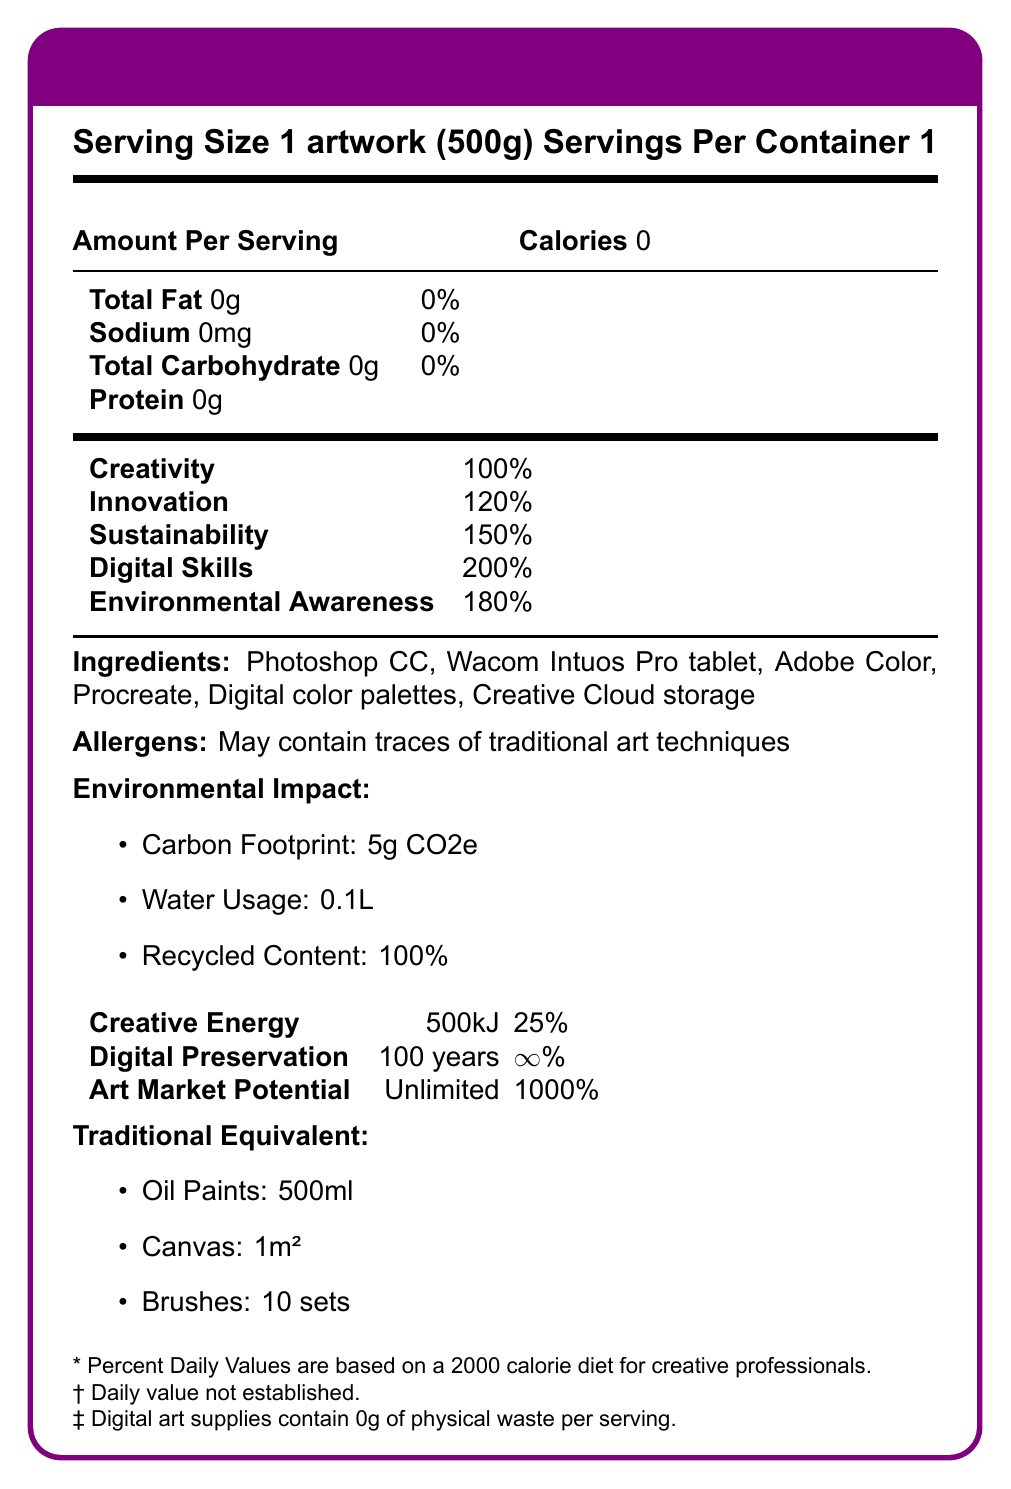What is the serving size of the artwork? The serving size is mentioned at the top of the label as "Serving Size 1 artwork (500g)".
Answer: 1 artwork (500g) How many calories are there per serving? The number of calories per serving is listed as 0 under "Amount Per Serving".
Answer: 0 What is the daily value percentage of Creativity? The daily value percentage of Creativity is given as 100%.
Answer: 100% Which ingredient might contain traces of traditional art techniques? Under "Allergens," it is mentioned that "May contain traces of traditional art techniques," referring to all the listed ingredients.
Answer: All of them What is the water usage for digital art supplies per serving? The "Environmental Impact" section lists the water usage as 0.1L.
Answer: 0.1L What is the carbon footprint of digital art supplies? A. 5g CO2e B. 100g CO2e C. 500g CO2e D. 10g CO2e The correct option is A, as stated under "Environmental Impact".
Answer: A. 5g CO2e Which of the following is not listed as an ingredient? A. Photoshop CC B. Wacom Intuos Pro tablet C. Paint brushes D. Procreate Paint brushes are not listed as an ingredient.
Answer: C. Paint brushes Does the digital art nutrition facts label list any protein content? The protein content is listed as 0g.
Answer: No Summarize the digital art nutrition facts document. The document mimics a nutrition label to inform about the benefits and components of digital art supplies. It compares them to traditional art materials and emphasizes their sustainability and creativity.
Answer: The document provides a nutrition facts label for digital art supplies, listing values such as calories, fat, sodium, carbohydrates, protein, vitamins, and minerals. It includes ingredients like Photoshop CC and Procreate, mentions allergens, and highlights the environmental impact and art market potential. It makes a comparison with traditional art supplies and emphasizes the sustainability and creativity benefits of digital art. What is the daily value percentage of Environmental Awareness? The daily value percentage of Environmental Awareness is listed as 180%.
Answer: 180% For how long are digital artworks preserved according to the label? The "Digital Preservation" section lists the preservation time as 100 years.
Answer: 100 years How many servings are in one container? The label states "Servings Per Container 1" at the top.
Answer: 1 Can you determine the specific carbon footprint of traditional art supplies from this document? The document only provides the carbon footprint for digital art supplies, which is 5g CO2e. It does not specify the carbon footprint of traditional art supplies.
Answer: Not enough information What is the art market potential percentage for digital art? The "Art Market Potential" section lists the potential as "Unlimited" and 1000%.
Answer: 1000% What is the creative energy provided by digital art supplies per serving? The "Creative Energy" section lists the value as 500kJ, which is 25% of the daily value.
Answer: 500kJ 